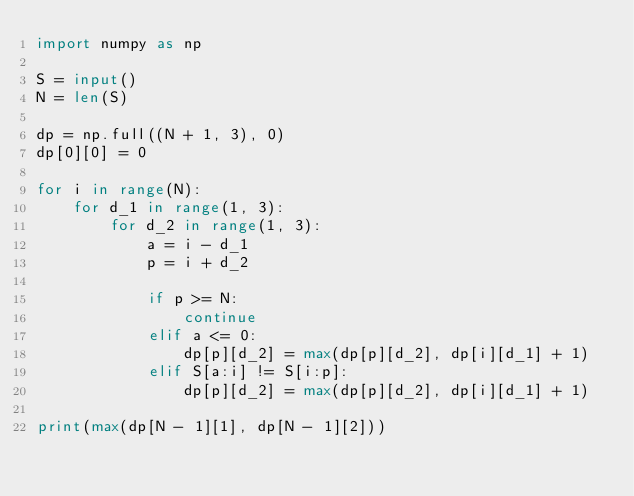Convert code to text. <code><loc_0><loc_0><loc_500><loc_500><_Python_>import numpy as np

S = input()
N = len(S)

dp = np.full((N + 1, 3), 0)
dp[0][0] = 0

for i in range(N):
    for d_1 in range(1, 3):
        for d_2 in range(1, 3):
            a = i - d_1
            p = i + d_2

            if p >= N:
                continue
            elif a <= 0:
                dp[p][d_2] = max(dp[p][d_2], dp[i][d_1] + 1)
            elif S[a:i] != S[i:p]:
                dp[p][d_2] = max(dp[p][d_2], dp[i][d_1] + 1)

print(max(dp[N - 1][1], dp[N - 1][2]))
</code> 